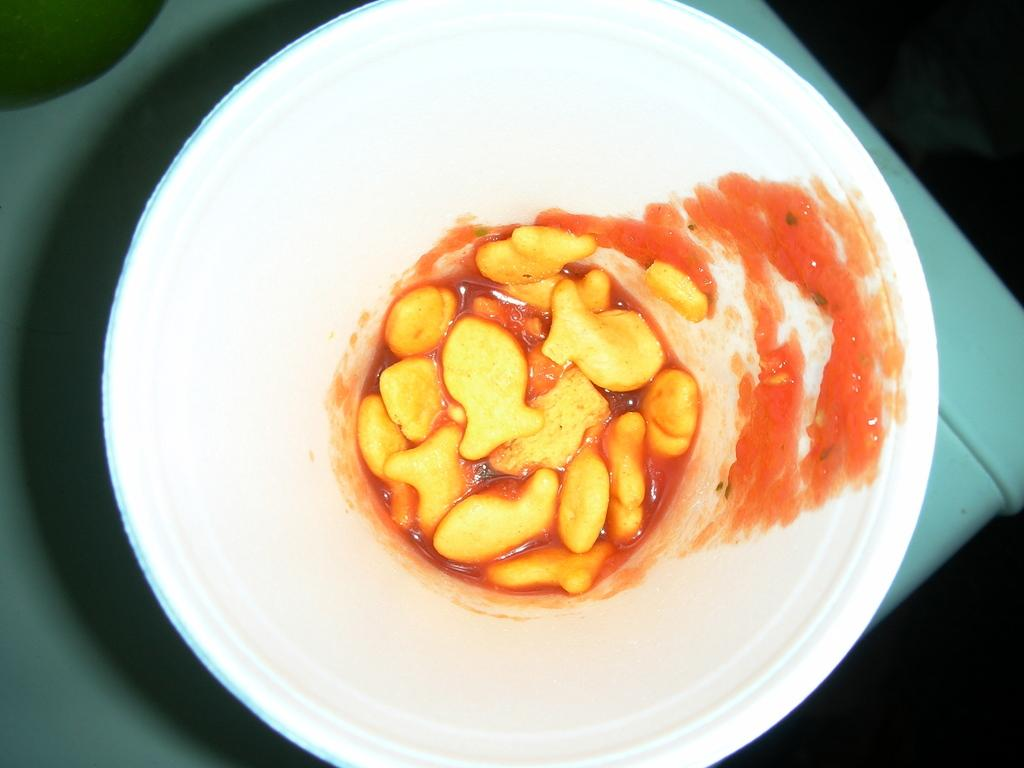What is contained in the glass that is visible in the image? There is food in a glass in the image. Where is the glass located in the image? The glass is on the table in the image. What else can be seen on the table in the image? There is an object on the table in the image. What type of plants are growing on the chin of the person in the image? There is no person or chin present in the image, so it is not possible to answer that question. 